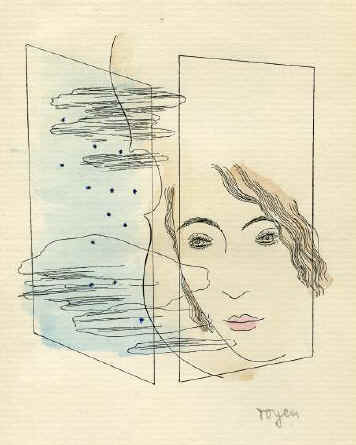What is this photo about? The image features a thought-provoking piece of art, showcasing a woman's face depicted through delicate line art combined with abstract elements. The face, outlined in bold black strokes, is set against an intriguing background of abstract blue and black forms that might suggest emotional depth or psychological complexity. This stylistic blending hints at themes of identity and perception, characteristic of surrealism, evoking a sense of mystery and introspection. Notably, the artist 'royer' signs the bottom right corner, linking their artistic identity to this evocative composition. 